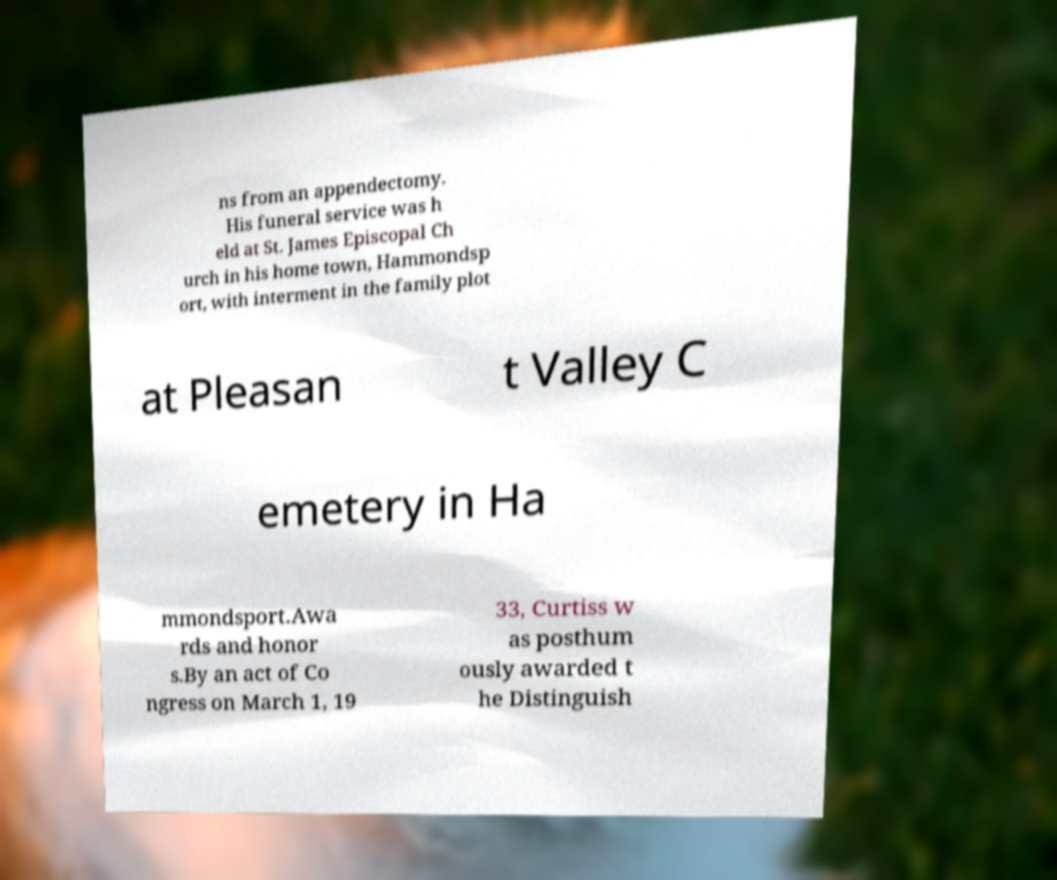Please identify and transcribe the text found in this image. ns from an appendectomy. His funeral service was h eld at St. James Episcopal Ch urch in his home town, Hammondsp ort, with interment in the family plot at Pleasan t Valley C emetery in Ha mmondsport.Awa rds and honor s.By an act of Co ngress on March 1, 19 33, Curtiss w as posthum ously awarded t he Distinguish 